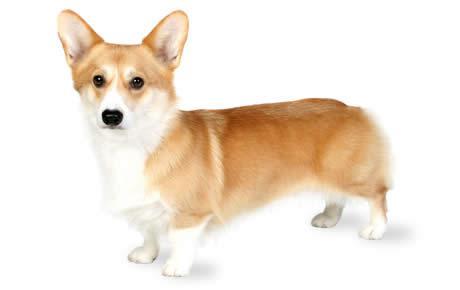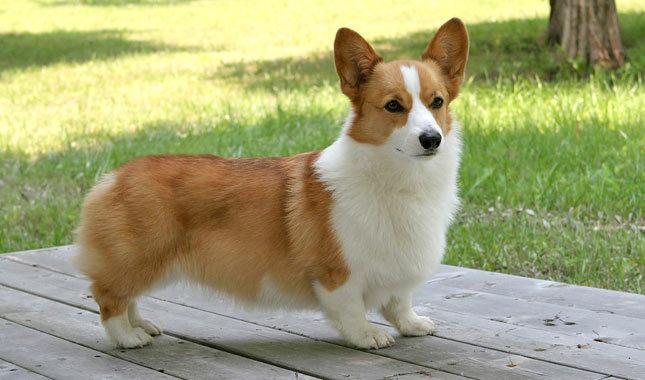The first image is the image on the left, the second image is the image on the right. Evaluate the accuracy of this statement regarding the images: "All the dogs are facing right in the right image.". Is it true? Answer yes or no. Yes. 